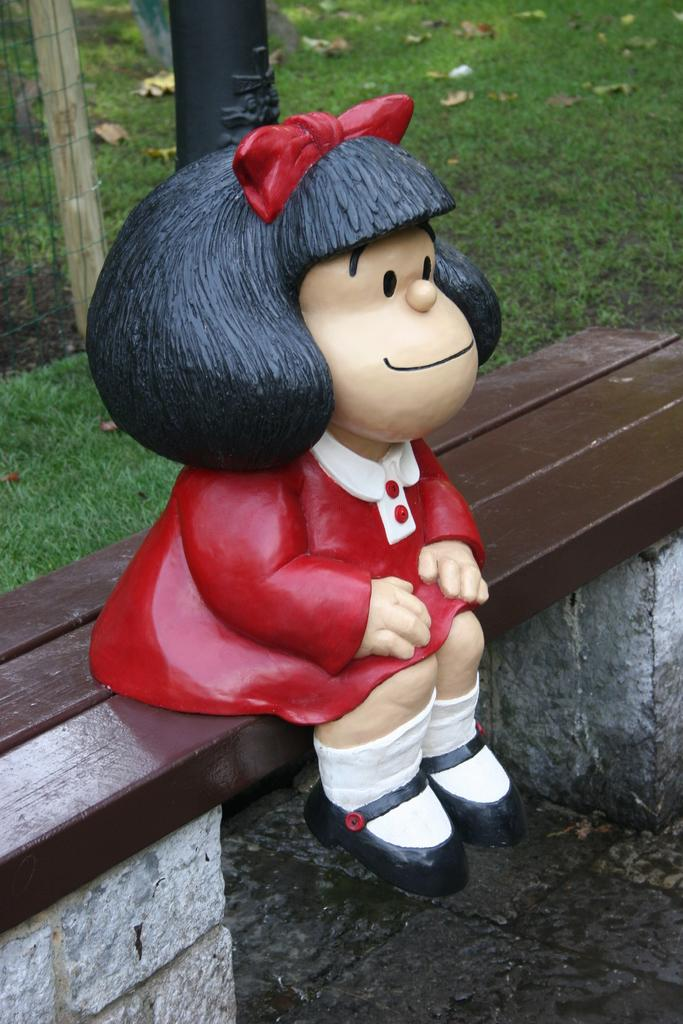What is the main subject in the center of the picture? There is a toy in the center of the picture. Where is the toy located? The toy is on a bench. What can be seen at the top of the image? There are dry leaves, grass, and fencing at the top of the image. What type of clover can be seen growing near the toy in the image? There is no clover visible in the image; only dry leaves, grass, and fencing are present at the top of the image. 